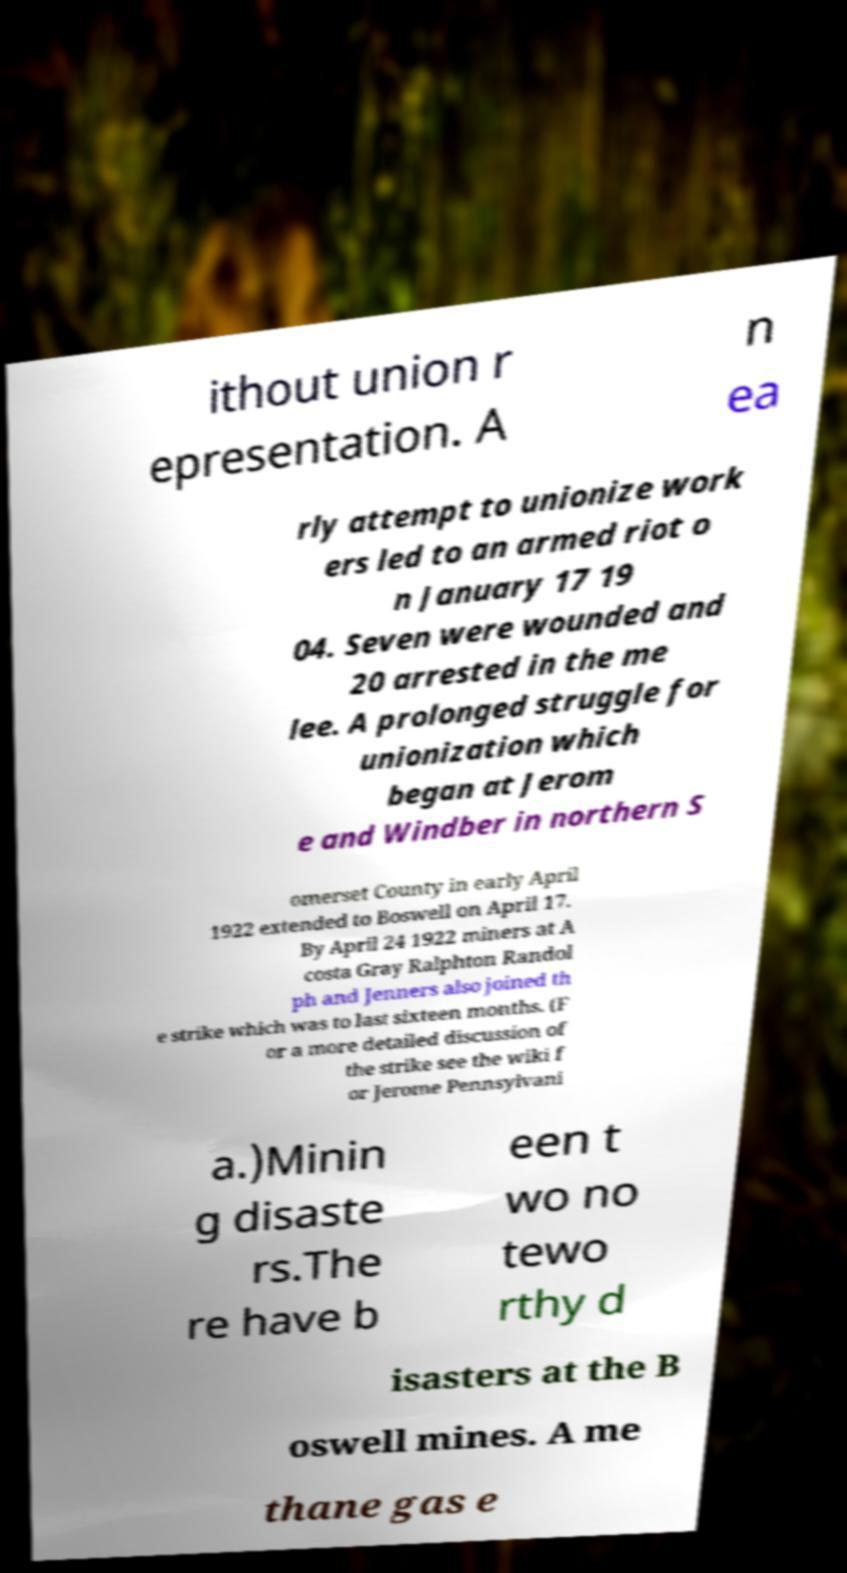Can you accurately transcribe the text from the provided image for me? ithout union r epresentation. A n ea rly attempt to unionize work ers led to an armed riot o n January 17 19 04. Seven were wounded and 20 arrested in the me lee. A prolonged struggle for unionization which began at Jerom e and Windber in northern S omerset County in early April 1922 extended to Boswell on April 17. By April 24 1922 miners at A costa Gray Ralphton Randol ph and Jenners also joined th e strike which was to last sixteen months. (F or a more detailed discussion of the strike see the wiki f or Jerome Pennsylvani a.)Minin g disaste rs.The re have b een t wo no tewo rthy d isasters at the B oswell mines. A me thane gas e 